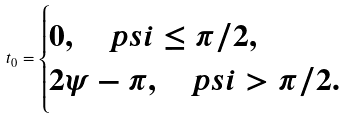<formula> <loc_0><loc_0><loc_500><loc_500>\ t _ { 0 } = \begin{cases} 0 , \quad p s i \leq \pi / 2 , \\ 2 \psi - \pi , \quad p s i > \pi / 2 . \end{cases}</formula> 